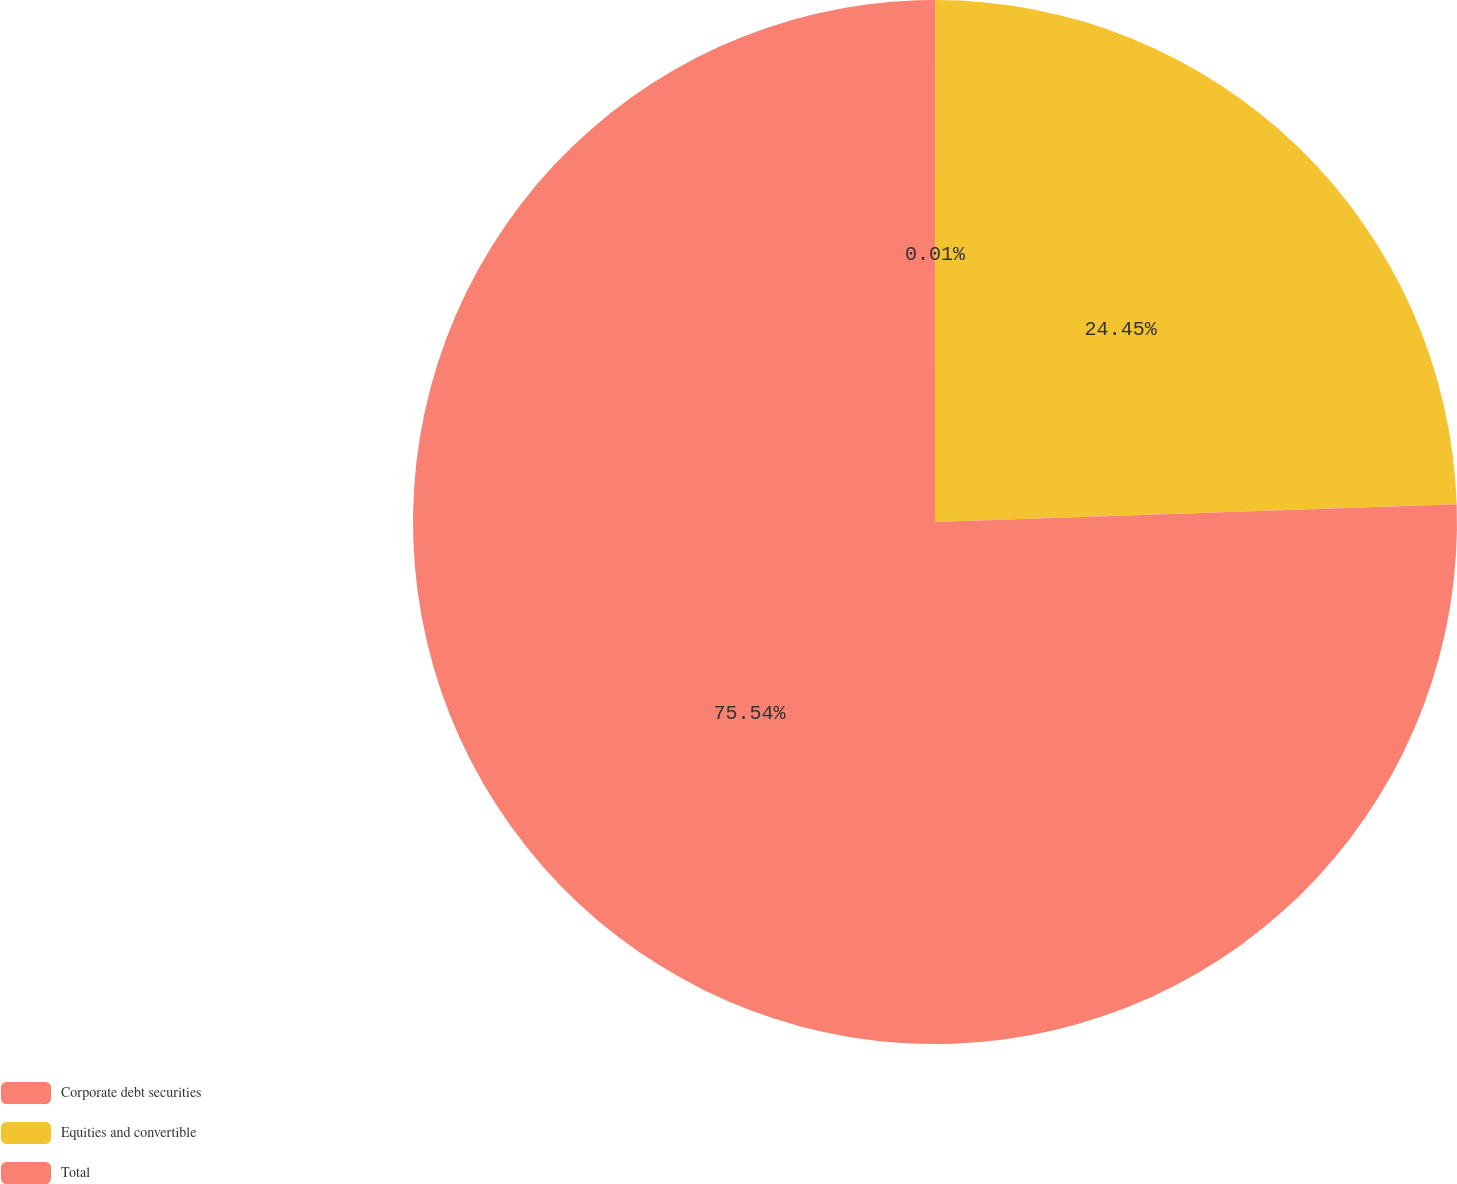Convert chart. <chart><loc_0><loc_0><loc_500><loc_500><pie_chart><fcel>Corporate debt securities<fcel>Equities and convertible<fcel>Total<nl><fcel>0.01%<fcel>24.45%<fcel>75.54%<nl></chart> 